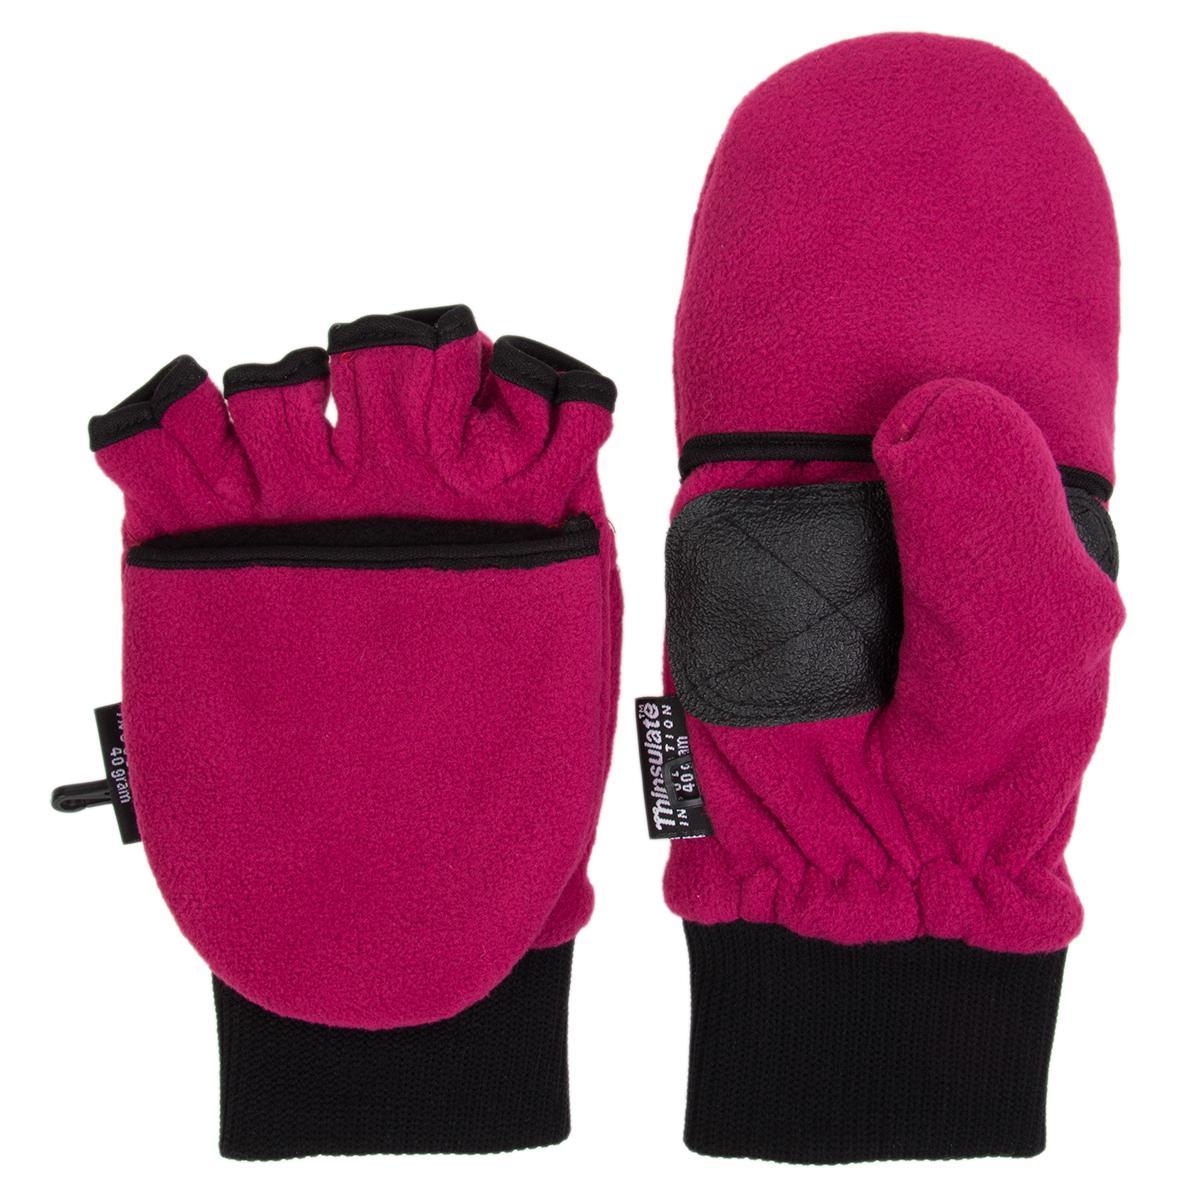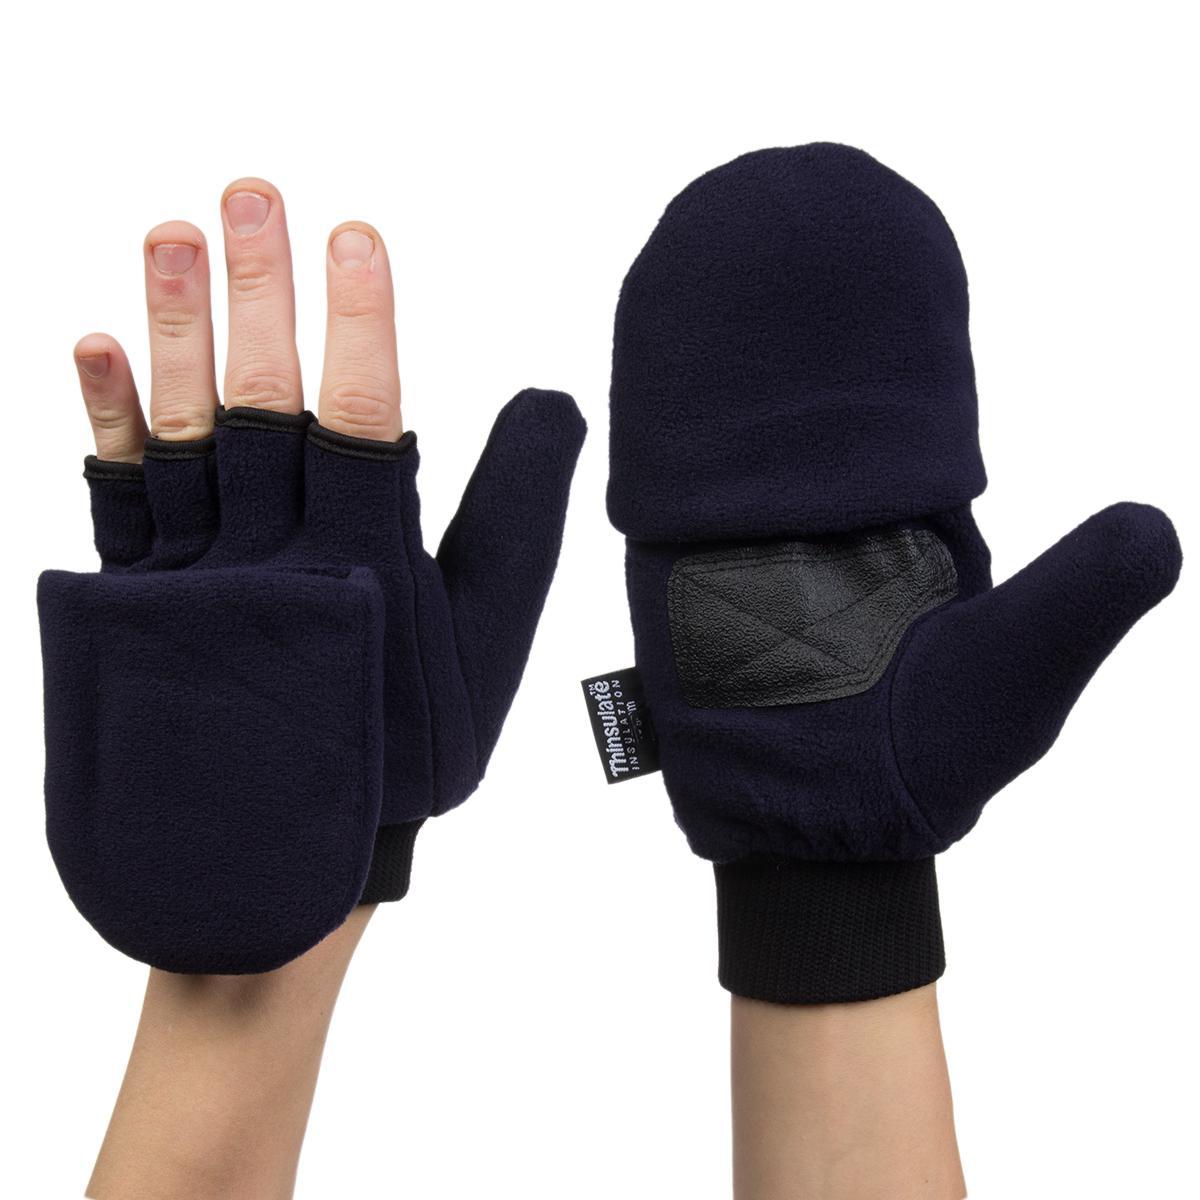The first image is the image on the left, the second image is the image on the right. Analyze the images presented: Is the assertion "Each pair of mittens includes at least one with a rounded covered top, and no mitten has four full-length fingers with tips." valid? Answer yes or no. Yes. The first image is the image on the left, the second image is the image on the right. Examine the images to the left and right. Is the description "There are two gloves without fingers." accurate? Answer yes or no. Yes. 